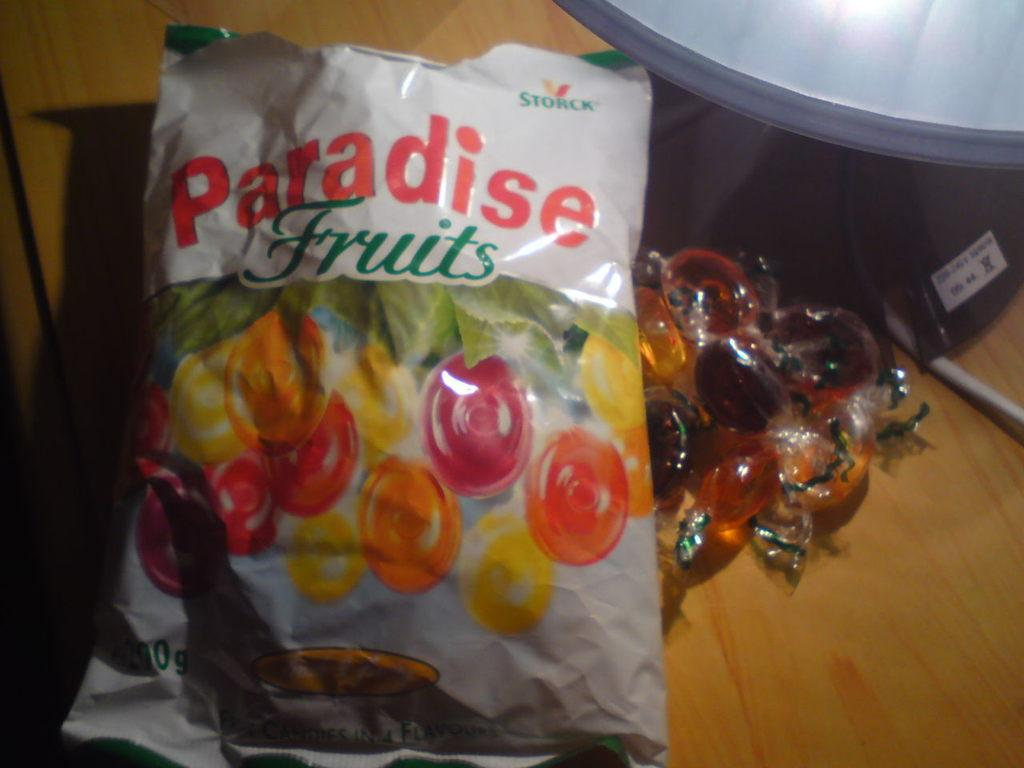What is the main subject of the image? The main subject of the image is a packet with text and an image. What else can be seen in the image besides the packet? There are candies beside the packet. Is there any other object present on the table in the image? Yes, there is an object on the table in the image. In which direction is the building located in the image? There is no building present in the image. What type of sail can be seen on the object on the table? There is no sail present in the image, and the object on the table is not specified. 